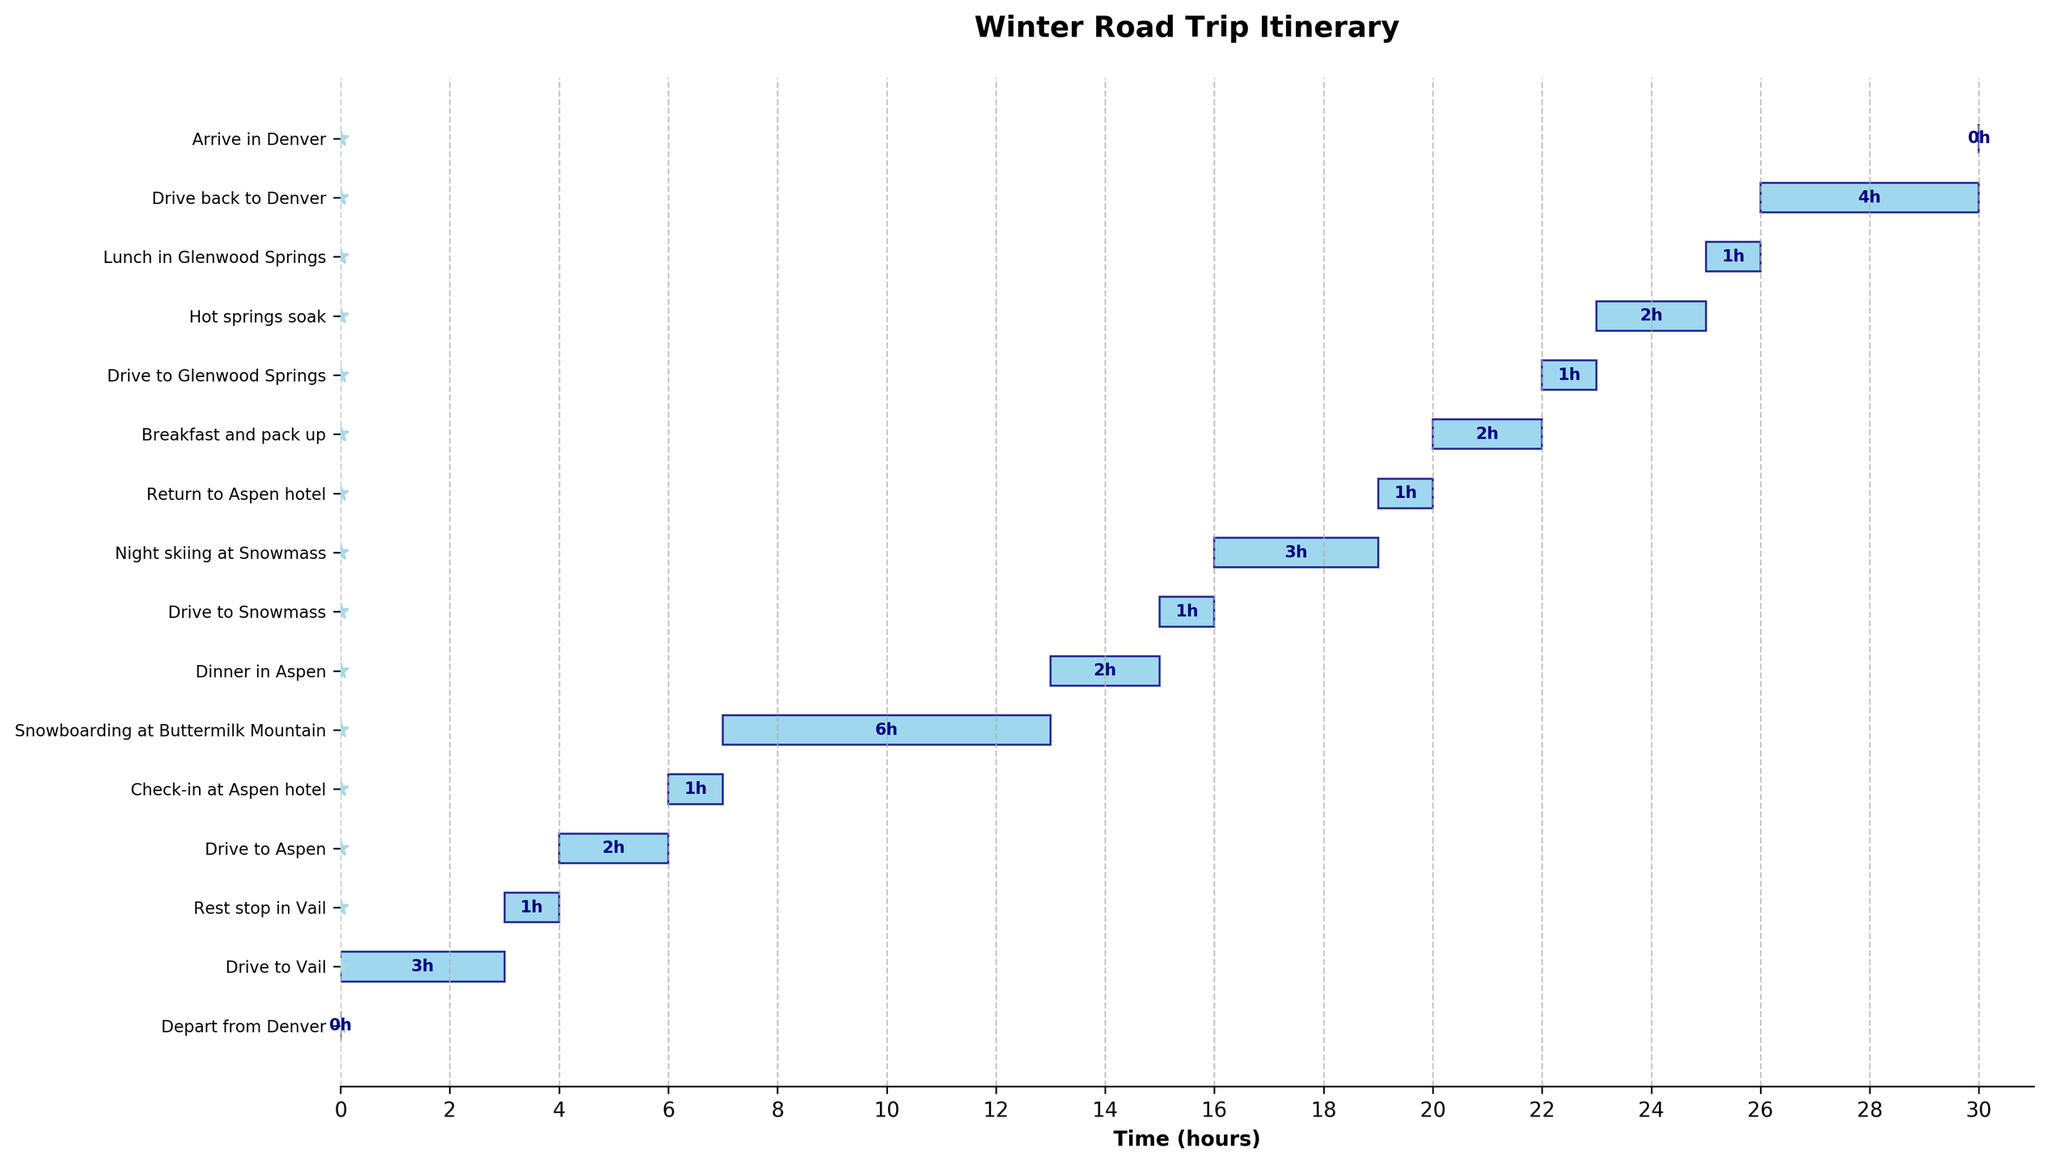What is the duration of the "Snowboarding at Buttermilk Mountain" activity? Locate the "Snowboarding at Buttermilk Mountain" task on the y-axis, then check the length of its bar along the x-axis, which starts at hour 7 and ends at hour 13, giving a duration of 6 hours.
Answer: 6 hours How much time is spent driving, including all driving sections? Add up the durations of all driving sections: Drive to Vail (3 hours), Drive to Aspen (2 hours), Drive to Snowmass (1 hour), and Drive to Glenwood Springs (1 hour), and Drive back to Denver (4 hours). 3 + 2 + 1 + 1 + 4 = 11 hours.
Answer: 11 hours What is the total time allocated for rest stops and meals? Sum the durations of all rest stops and meals: Rest stop in Vail (1 hour), Dinner in Aspen (2 hours), Breakfast and pack up (2 hours), Lunch in Glenwood Springs (1 hour). 1 + 2 + 2 + 1 = 6 hours.
Answer: 6 hours Which activity takes the longest duration? Compare the lengths of all bars representing the tasks. The longest bar is "Snowboarding at Buttermilk Mountain," which lasts for 6 hours.
Answer: Snowboarding at Buttermilk Mountain How long is the trip from departure to arrival in Denver? Check the x-axis values from the start of the first task, "Depart from Denver" at hour 0, to the end of the last task, "Arrive in Denver" at hour 30, giving a total trip duration of 30 hours.
Answer: 30 hours When does "Night skiing at Snowmass" start and end? Find the "Night skiing at Snowmass" task on the y-axis, and read its start (hour 16) and end times (hour 19) from the x-axis.
Answer: Starts at hour 16 and ends at hour 19 Which activity directly follows "Check-in at Aspen hotel"? Locate the "Check-in at Aspen hotel" on the y-axis to see the next activity, which is "Snowboarding at Buttermilk Mountain."
Answer: Snowboarding at Buttermilk Mountain How many different stops are made before reaching Aspen? Identify the tasks before "Check-in at Aspen hotel": "Depart from Denver," "Drive to Vail," "Rest stop in Vail," and "Drive to Aspen." There are 4 distinct sections before reaching Aspen.
Answer: 4 stops What is the average duration of all sightseeing activities? Identify the sightseeing activities: Snowboarding at Buttermilk Mountain (6 hours), Night skiing at Snowmass (3 hours), Hot springs soak (2 hours). Calculate the average: (6 + 3 + 2) / 3 = 11 / 3 = 3.67 hours.
Answer: 3.67 hours 